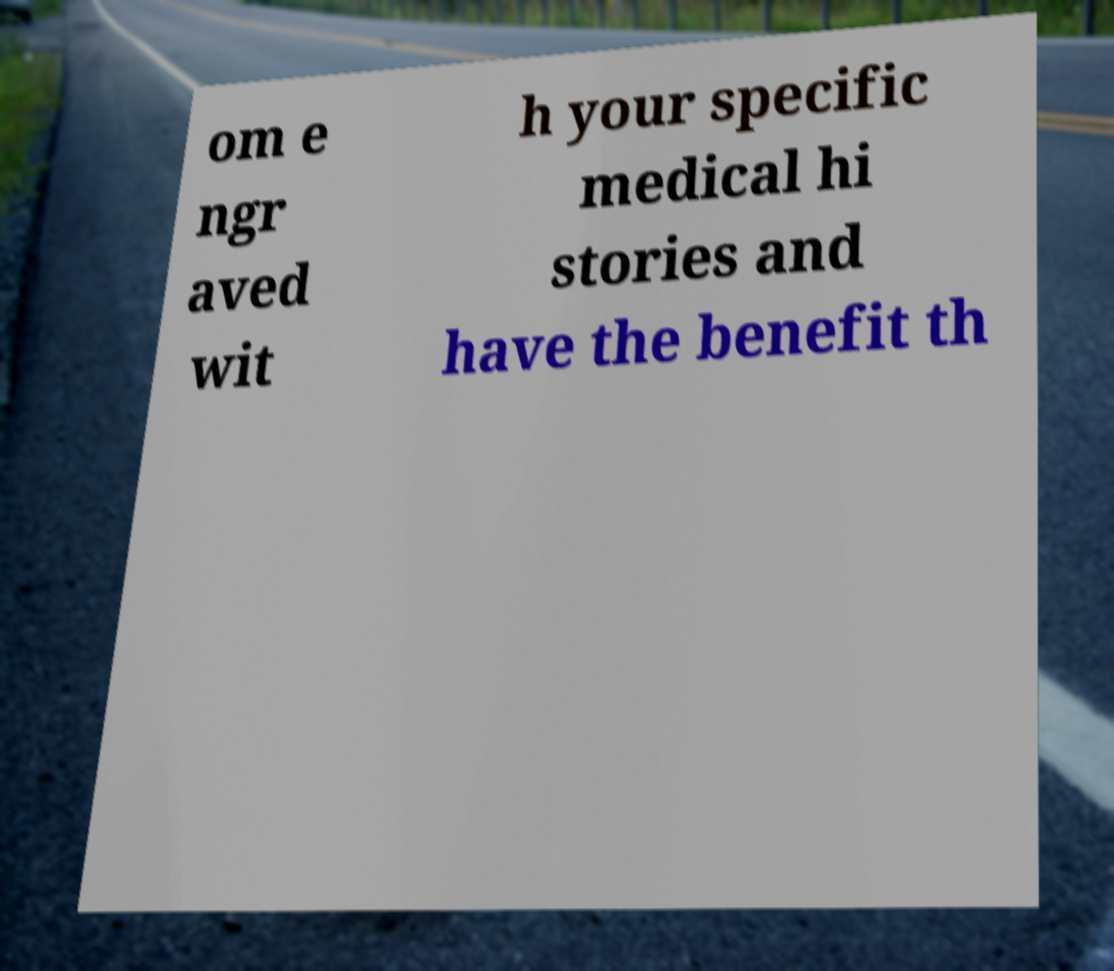Can you read and provide the text displayed in the image?This photo seems to have some interesting text. Can you extract and type it out for me? om e ngr aved wit h your specific medical hi stories and have the benefit th 